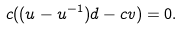Convert formula to latex. <formula><loc_0><loc_0><loc_500><loc_500>c ( ( u - u ^ { - 1 } ) d - c v ) = 0 .</formula> 